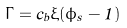<formula> <loc_0><loc_0><loc_500><loc_500>\Gamma = c _ { b } \xi ( \phi _ { s } - 1 )</formula> 